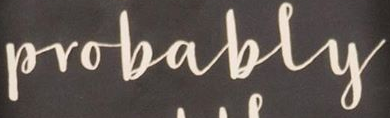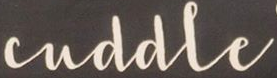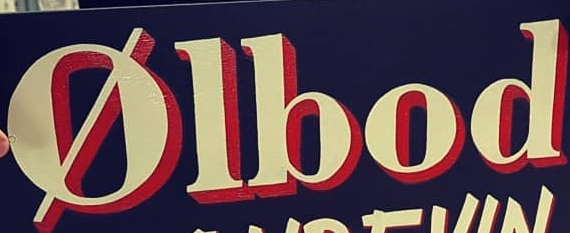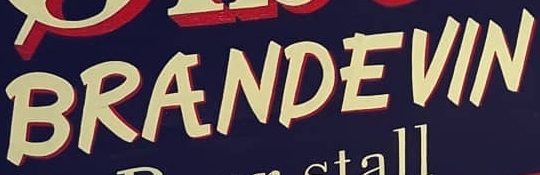Read the text from these images in sequence, separated by a semicolon. Probably; cuddle; Ølbod; BRANDEVIN 